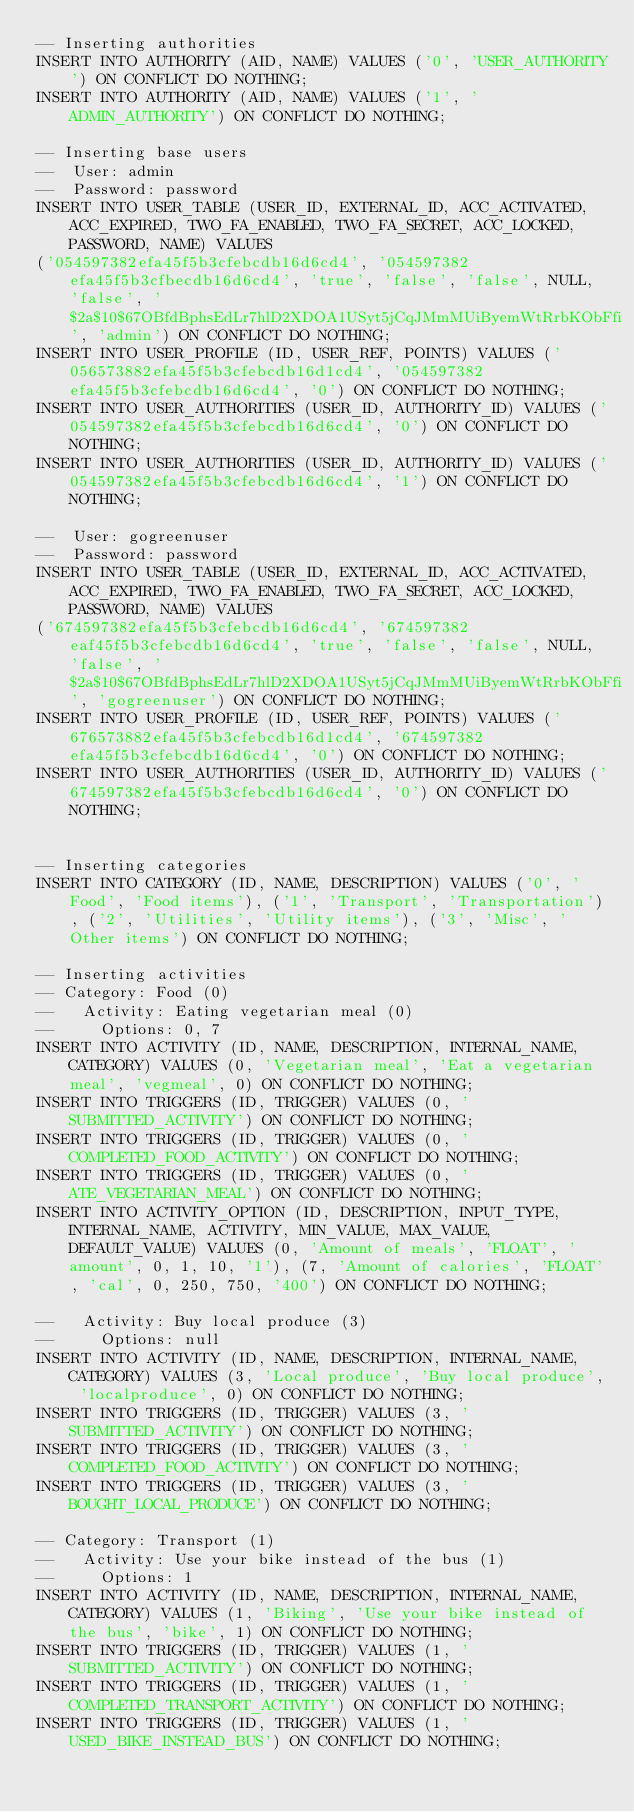Convert code to text. <code><loc_0><loc_0><loc_500><loc_500><_SQL_>-- Inserting authorities
INSERT INTO AUTHORITY (AID, NAME) VALUES ('0', 'USER_AUTHORITY') ON CONFLICT DO NOTHING;
INSERT INTO AUTHORITY (AID, NAME) VALUES ('1', 'ADMIN_AUTHORITY') ON CONFLICT DO NOTHING;

-- Inserting base users
--  User: admin
--  Password: password
INSERT INTO USER_TABLE (USER_ID, EXTERNAL_ID, ACC_ACTIVATED, ACC_EXPIRED, TWO_FA_ENABLED, TWO_FA_SECRET, ACC_LOCKED, PASSWORD, NAME) VALUES
('054597382efa45f5b3cfebcdb16d6cd4', '054597382efa45f5b3cfbecdb16d6cd4', 'true', 'false', 'false', NULL, 'false', '$2a$10$67OBfdBphsEdLr7hlD2XDOA1USyt5jCqJMmMUiByemWtRrbKObFfi', 'admin') ON CONFLICT DO NOTHING;
INSERT INTO USER_PROFILE (ID, USER_REF, POINTS) VALUES ('056573882efa45f5b3cfebcdb16d1cd4', '054597382efa45f5b3cfebcdb16d6cd4', '0') ON CONFLICT DO NOTHING;
INSERT INTO USER_AUTHORITIES (USER_ID, AUTHORITY_ID) VALUES ('054597382efa45f5b3cfebcdb16d6cd4', '0') ON CONFLICT DO NOTHING;
INSERT INTO USER_AUTHORITIES (USER_ID, AUTHORITY_ID) VALUES ('054597382efa45f5b3cfebcdb16d6cd4', '1') ON CONFLICT DO NOTHING;

--  User: gogreenuser
--  Password: password
INSERT INTO USER_TABLE (USER_ID, EXTERNAL_ID, ACC_ACTIVATED, ACC_EXPIRED, TWO_FA_ENABLED, TWO_FA_SECRET, ACC_LOCKED, PASSWORD, NAME) VALUES
('674597382efa45f5b3cfebcdb16d6cd4', '674597382eaf45f5b3cfebcdb16d6cd4', 'true', 'false', 'false', NULL, 'false', '$2a$10$67OBfdBphsEdLr7hlD2XDOA1USyt5jCqJMmMUiByemWtRrbKObFfi', 'gogreenuser') ON CONFLICT DO NOTHING;
INSERT INTO USER_PROFILE (ID, USER_REF, POINTS) VALUES ('676573882efa45f5b3cfebcdb16d1cd4', '674597382efa45f5b3cfebcdb16d6cd4', '0') ON CONFLICT DO NOTHING;
INSERT INTO USER_AUTHORITIES (USER_ID, AUTHORITY_ID) VALUES ('674597382efa45f5b3cfebcdb16d6cd4', '0') ON CONFLICT DO NOTHING;


-- Inserting categories
INSERT INTO CATEGORY (ID, NAME, DESCRIPTION) VALUES ('0', 'Food', 'Food items'), ('1', 'Transport', 'Transportation'), ('2', 'Utilities', 'Utility items'), ('3', 'Misc', 'Other items') ON CONFLICT DO NOTHING;

-- Inserting activities
-- Category: Food (0)
--   Activity: Eating vegetarian meal (0)
--     Options: 0, 7
INSERT INTO ACTIVITY (ID, NAME, DESCRIPTION, INTERNAL_NAME, CATEGORY) VALUES (0, 'Vegetarian meal', 'Eat a vegetarian meal', 'vegmeal', 0) ON CONFLICT DO NOTHING;
INSERT INTO TRIGGERS (ID, TRIGGER) VALUES (0, 'SUBMITTED_ACTIVITY') ON CONFLICT DO NOTHING;
INSERT INTO TRIGGERS (ID, TRIGGER) VALUES (0, 'COMPLETED_FOOD_ACTIVITY') ON CONFLICT DO NOTHING;
INSERT INTO TRIGGERS (ID, TRIGGER) VALUES (0, 'ATE_VEGETARIAN_MEAL') ON CONFLICT DO NOTHING;
INSERT INTO ACTIVITY_OPTION (ID, DESCRIPTION, INPUT_TYPE, INTERNAL_NAME, ACTIVITY, MIN_VALUE, MAX_VALUE, DEFAULT_VALUE) VALUES (0, 'Amount of meals', 'FLOAT', 'amount', 0, 1, 10, '1'), (7, 'Amount of calories', 'FLOAT', 'cal', 0, 250, 750, '400') ON CONFLICT DO NOTHING;

--   Activity: Buy local produce (3)
--     Options: null
INSERT INTO ACTIVITY (ID, NAME, DESCRIPTION, INTERNAL_NAME, CATEGORY) VALUES (3, 'Local produce', 'Buy local produce', 'localproduce', 0) ON CONFLICT DO NOTHING;
INSERT INTO TRIGGERS (ID, TRIGGER) VALUES (3, 'SUBMITTED_ACTIVITY') ON CONFLICT DO NOTHING;
INSERT INTO TRIGGERS (ID, TRIGGER) VALUES (3, 'COMPLETED_FOOD_ACTIVITY') ON CONFLICT DO NOTHING;
INSERT INTO TRIGGERS (ID, TRIGGER) VALUES (3, 'BOUGHT_LOCAL_PRODUCE') ON CONFLICT DO NOTHING;

-- Category: Transport (1)
--   Activity: Use your bike instead of the bus (1)
--     Options: 1
INSERT INTO ACTIVITY (ID, NAME, DESCRIPTION, INTERNAL_NAME, CATEGORY) VALUES (1, 'Biking', 'Use your bike instead of the bus', 'bike', 1) ON CONFLICT DO NOTHING;
INSERT INTO TRIGGERS (ID, TRIGGER) VALUES (1, 'SUBMITTED_ACTIVITY') ON CONFLICT DO NOTHING;
INSERT INTO TRIGGERS (ID, TRIGGER) VALUES (1, 'COMPLETED_TRANSPORT_ACTIVITY') ON CONFLICT DO NOTHING;
INSERT INTO TRIGGERS (ID, TRIGGER) VALUES (1, 'USED_BIKE_INSTEAD_BUS') ON CONFLICT DO NOTHING;</code> 